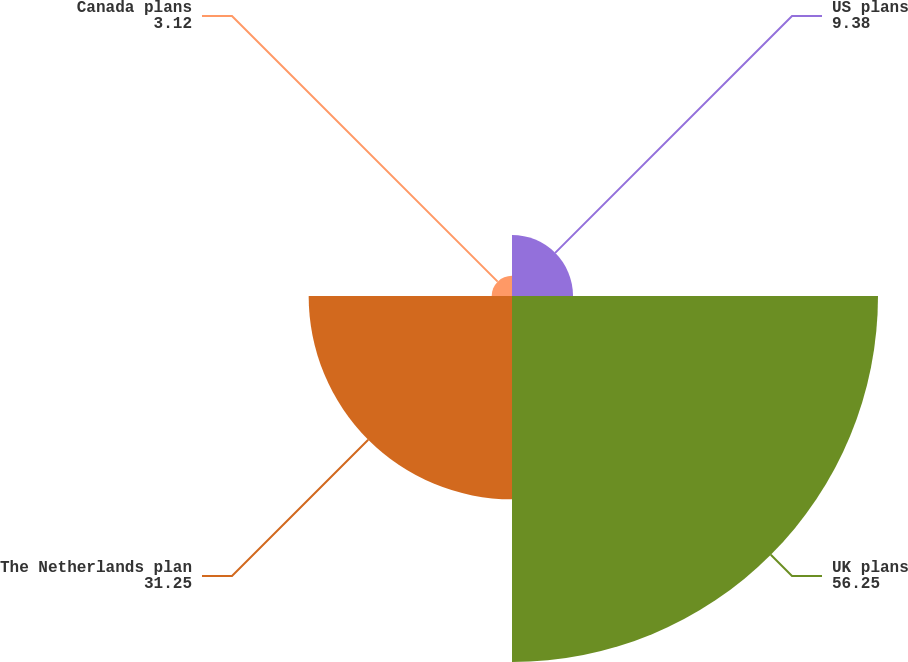Convert chart. <chart><loc_0><loc_0><loc_500><loc_500><pie_chart><fcel>US plans<fcel>UK plans<fcel>The Netherlands plan<fcel>Canada plans<nl><fcel>9.38%<fcel>56.25%<fcel>31.25%<fcel>3.12%<nl></chart> 